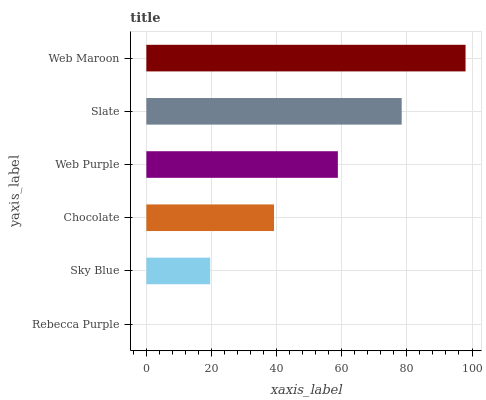Is Rebecca Purple the minimum?
Answer yes or no. Yes. Is Web Maroon the maximum?
Answer yes or no. Yes. Is Sky Blue the minimum?
Answer yes or no. No. Is Sky Blue the maximum?
Answer yes or no. No. Is Sky Blue greater than Rebecca Purple?
Answer yes or no. Yes. Is Rebecca Purple less than Sky Blue?
Answer yes or no. Yes. Is Rebecca Purple greater than Sky Blue?
Answer yes or no. No. Is Sky Blue less than Rebecca Purple?
Answer yes or no. No. Is Web Purple the high median?
Answer yes or no. Yes. Is Chocolate the low median?
Answer yes or no. Yes. Is Web Maroon the high median?
Answer yes or no. No. Is Sky Blue the low median?
Answer yes or no. No. 